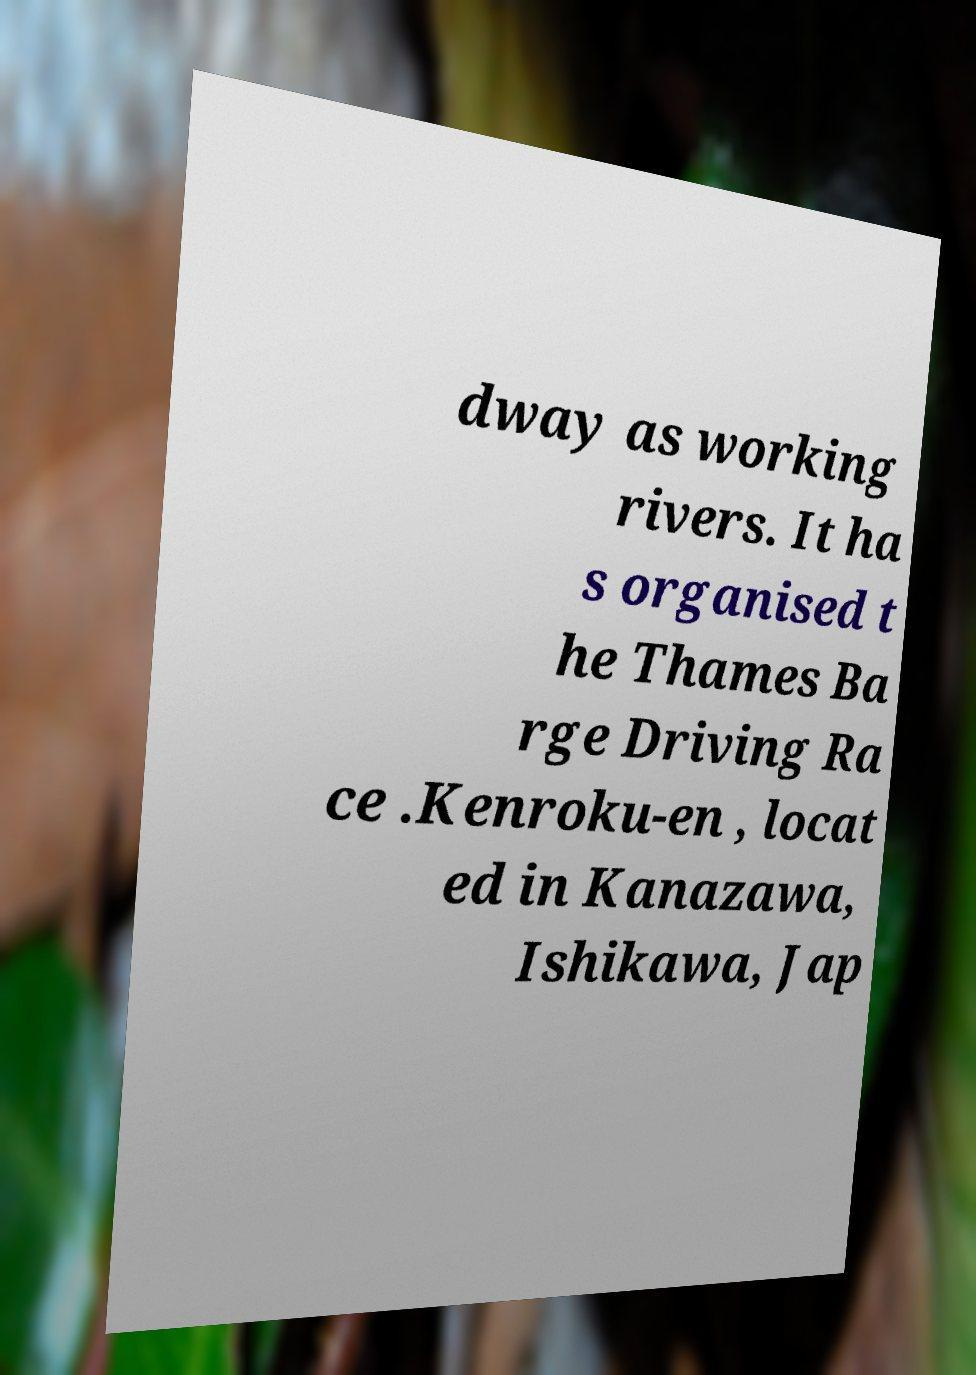Please identify and transcribe the text found in this image. dway as working rivers. It ha s organised t he Thames Ba rge Driving Ra ce .Kenroku-en , locat ed in Kanazawa, Ishikawa, Jap 